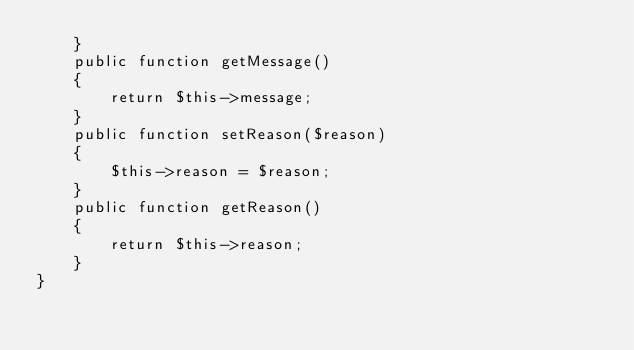<code> <loc_0><loc_0><loc_500><loc_500><_PHP_>    }
    public function getMessage()
    {
        return $this->message;
    }
    public function setReason($reason)
    {
        $this->reason = $reason;
    }
    public function getReason()
    {
        return $this->reason;
    }
}
</code> 